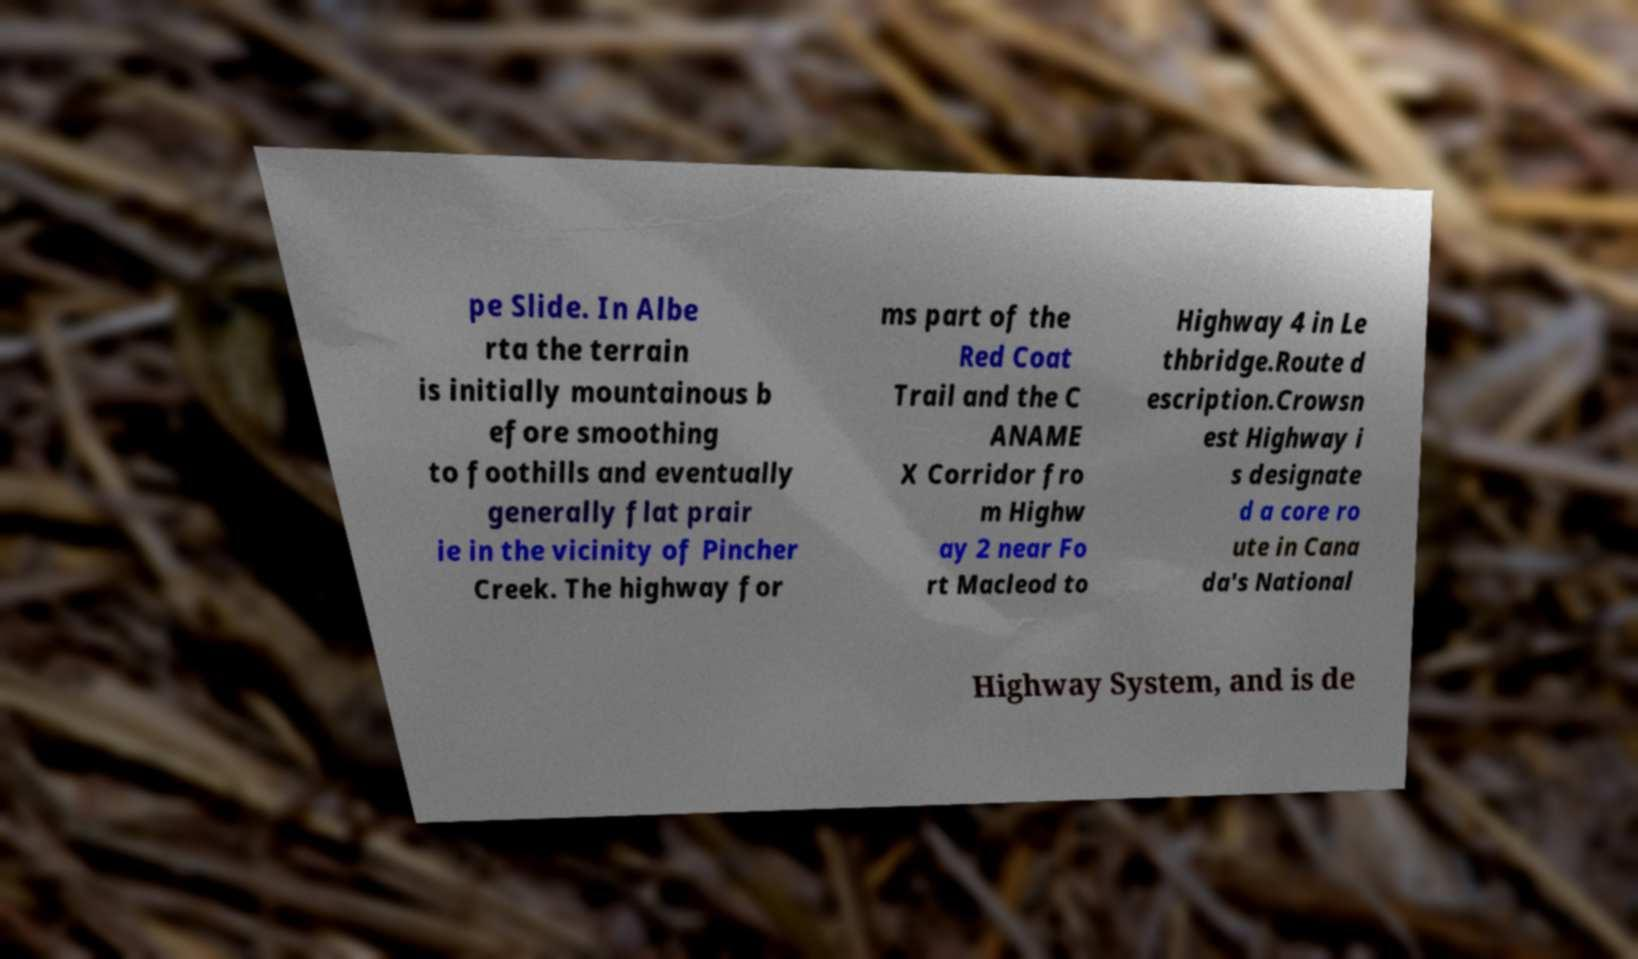There's text embedded in this image that I need extracted. Can you transcribe it verbatim? pe Slide. In Albe rta the terrain is initially mountainous b efore smoothing to foothills and eventually generally flat prair ie in the vicinity of Pincher Creek. The highway for ms part of the Red Coat Trail and the C ANAME X Corridor fro m Highw ay 2 near Fo rt Macleod to Highway 4 in Le thbridge.Route d escription.Crowsn est Highway i s designate d a core ro ute in Cana da's National Highway System, and is de 